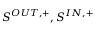<formula> <loc_0><loc_0><loc_500><loc_500>{ S ^ { O U T , + } , S ^ { I N , + } }</formula> 